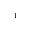<formula> <loc_0><loc_0><loc_500><loc_500>^ { - 1 }</formula> 